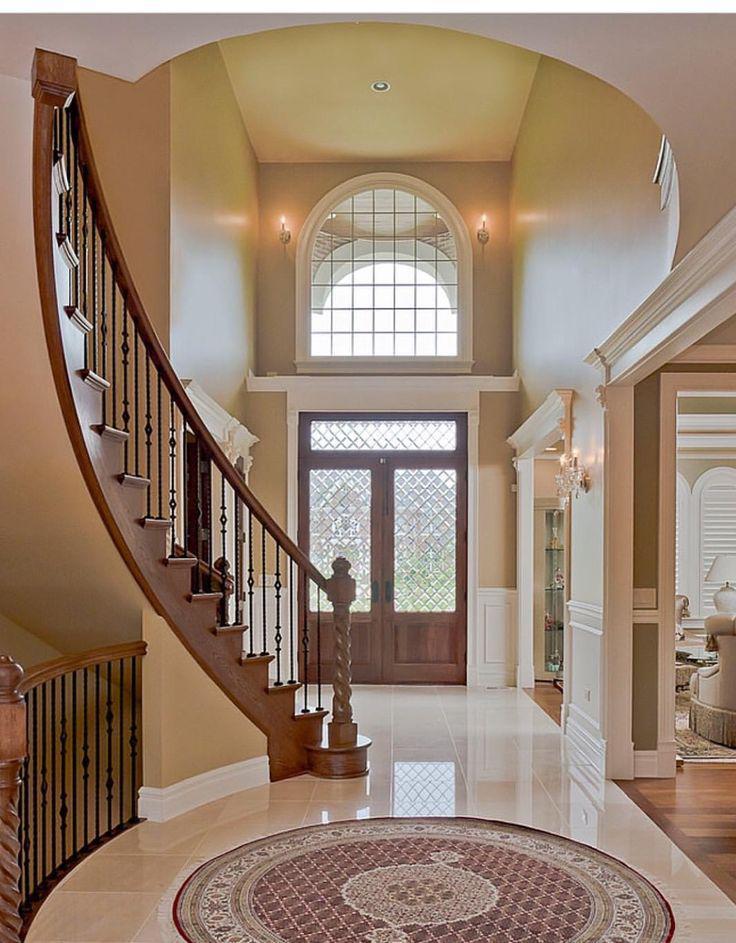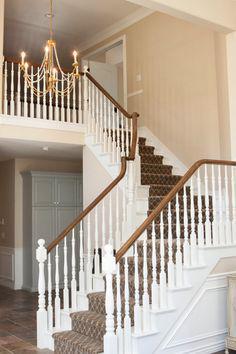The first image is the image on the left, the second image is the image on the right. Evaluate the accuracy of this statement regarding the images: "The left image features a curving staircase with a wooden handrail and vertical wrought iron bars with a dimensional decorative element.". Is it true? Answer yes or no. Yes. The first image is the image on the left, the second image is the image on the right. Given the left and right images, does the statement "In at least one image there are brown railed stair that curve as they come down to the floor." hold true? Answer yes or no. Yes. 